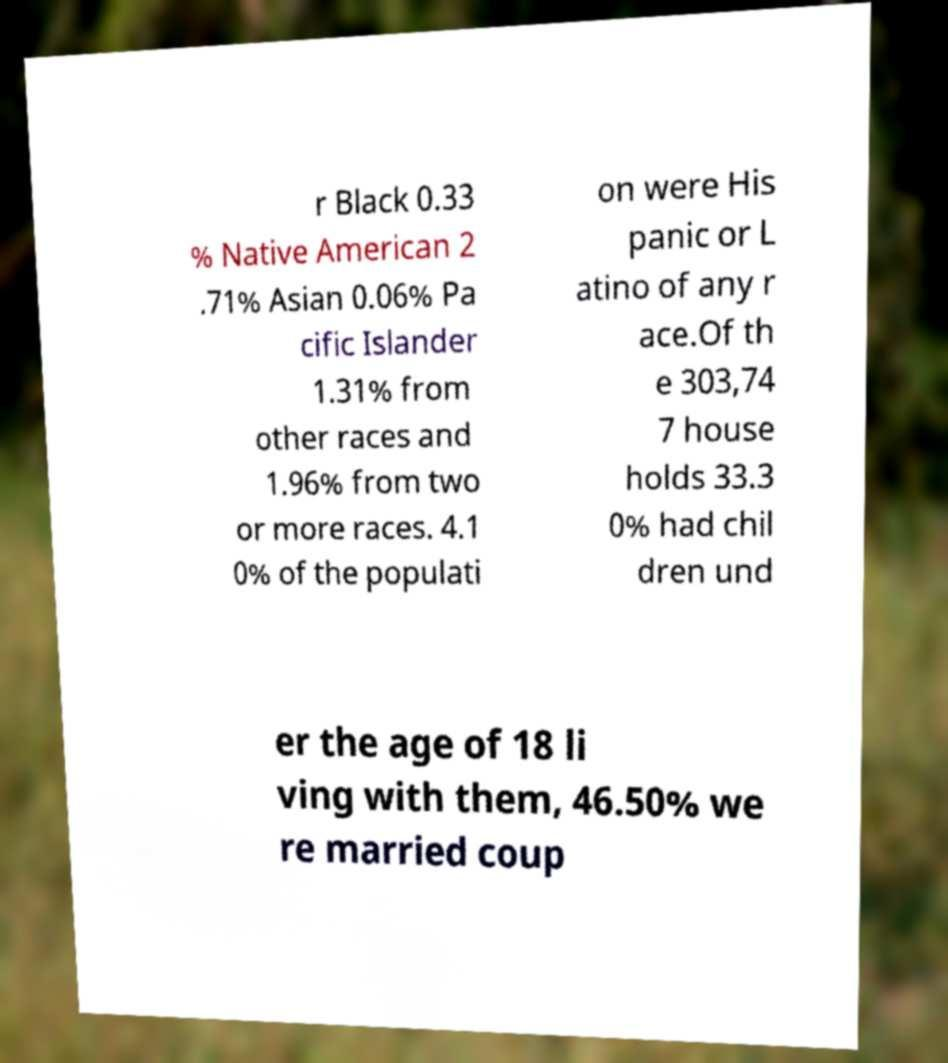Could you extract and type out the text from this image? r Black 0.33 % Native American 2 .71% Asian 0.06% Pa cific Islander 1.31% from other races and 1.96% from two or more races. 4.1 0% of the populati on were His panic or L atino of any r ace.Of th e 303,74 7 house holds 33.3 0% had chil dren und er the age of 18 li ving with them, 46.50% we re married coup 